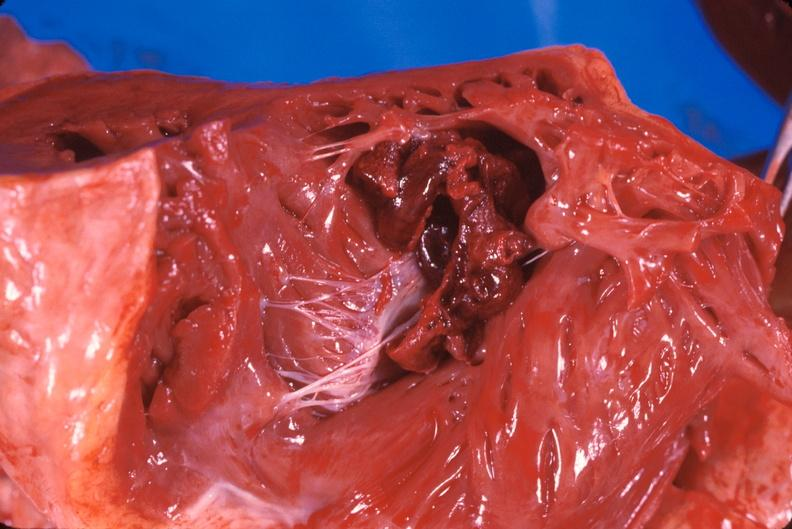s heart present?
Answer the question using a single word or phrase. Yes 